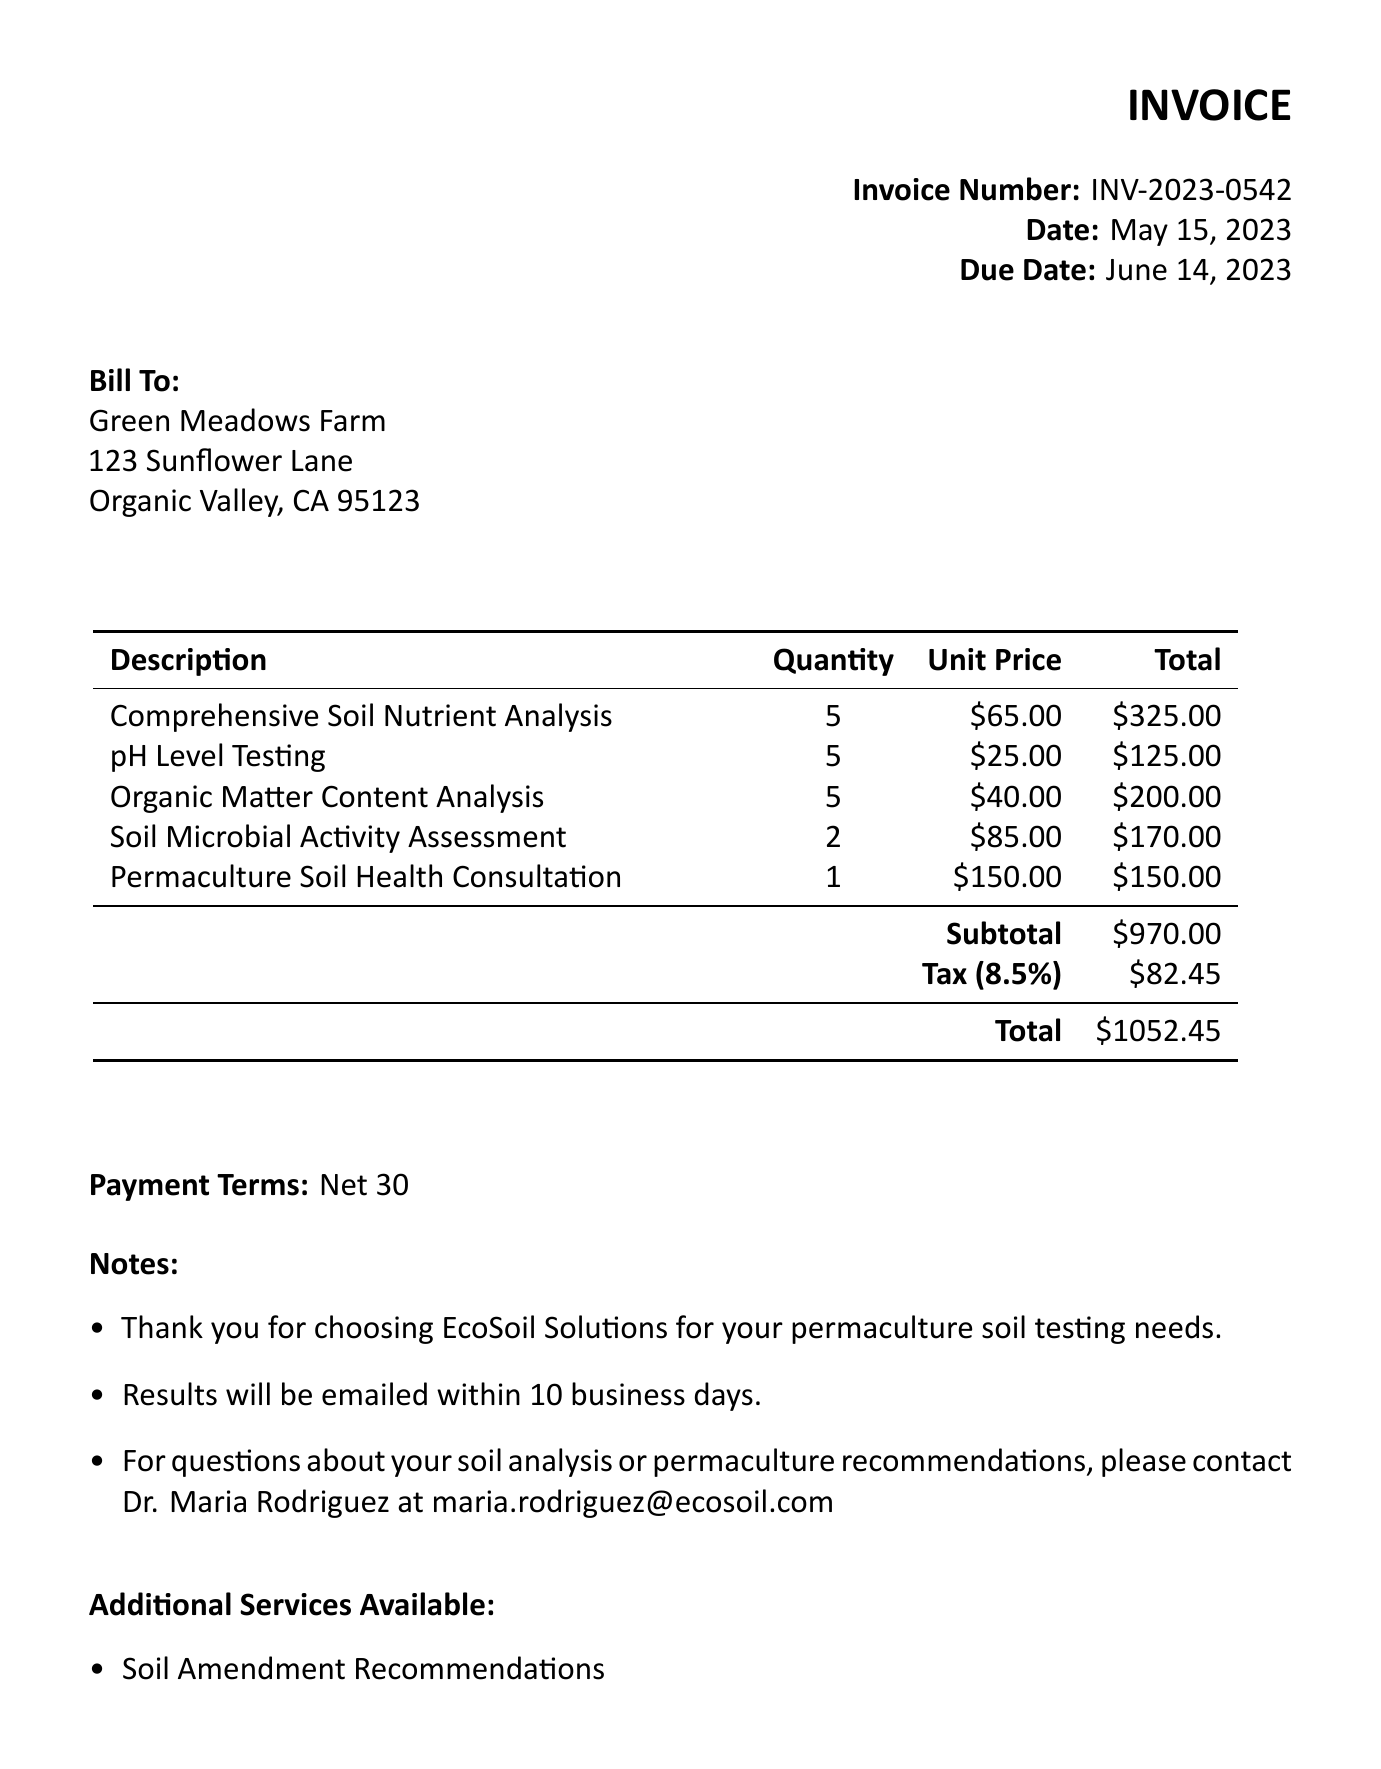What is the invoice number? The invoice number is listed at the top right of the document, labeled as "Invoice Number."
Answer: INV-2023-0542 What is the due date for this invoice? The due date is mentioned in the invoice details, indicating the date by which payment should be made.
Answer: June 14, 2023 Who is the client for this invoice? The "Bill To" section specifies the name of the client receiving the invoice.
Answer: Green Meadows Farm What is the subtotal amount? The subtotal is calculated before tax and is specified in a summarized table at the bottom of the charges.
Answer: $970.00 How many Organic Matter Content Analysis items were ordered? The quantity for each item is listed next to its description in the items table.
Answer: 5 What is the total amount due? The total is at the bottom of the invoice, presenting the final amount to be paid after tax.
Answer: $1052.45 Who can be contacted for questions about soil analysis? The notes section provides contact information for inquiries related to the soil analysis.
Answer: Dr. Maria Rodriguez What services are listed as additional services? The invoice includes a list of optional services available beyond the primary charges.
Answer: Soil Amendment Recommendations, Permaculture Design Consultation, Compost Tea Analysis What is the tax rate applied to the subtotal? The tax rate is mentioned alongside the subtotal and total in the payment table.
Answer: 8.5% 